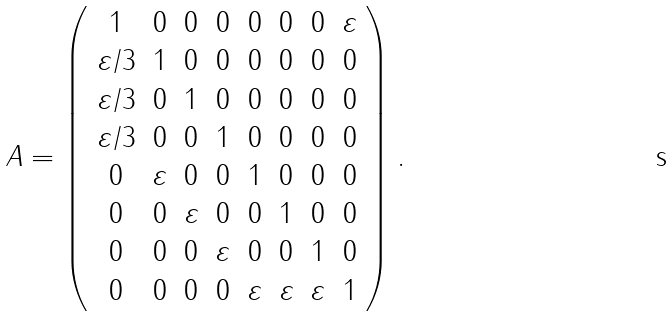<formula> <loc_0><loc_0><loc_500><loc_500>A = \left ( \begin{array} { c c c c c c c c } 1 & 0 & 0 & 0 & 0 & 0 & 0 & \varepsilon \\ \varepsilon / 3 & 1 & 0 & 0 & 0 & 0 & 0 & 0 \\ \varepsilon / 3 & 0 & 1 & 0 & 0 & 0 & 0 & 0 \\ \varepsilon / 3 & 0 & 0 & 1 & 0 & 0 & 0 & 0 \\ 0 & \varepsilon & 0 & 0 & 1 & 0 & 0 & 0 \\ 0 & 0 & \varepsilon & 0 & 0 & 1 & 0 & 0 \\ 0 & 0 & 0 & \varepsilon & 0 & 0 & 1 & 0 \\ 0 & 0 & 0 & 0 & \varepsilon & \varepsilon & \varepsilon & 1 \end{array} \right ) .</formula> 